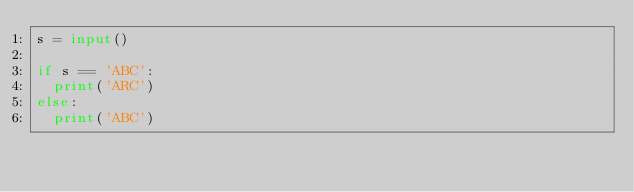Convert code to text. <code><loc_0><loc_0><loc_500><loc_500><_Python_>s = input()

if s == 'ABC':
  print('ARC')
else:
  print('ABC')</code> 